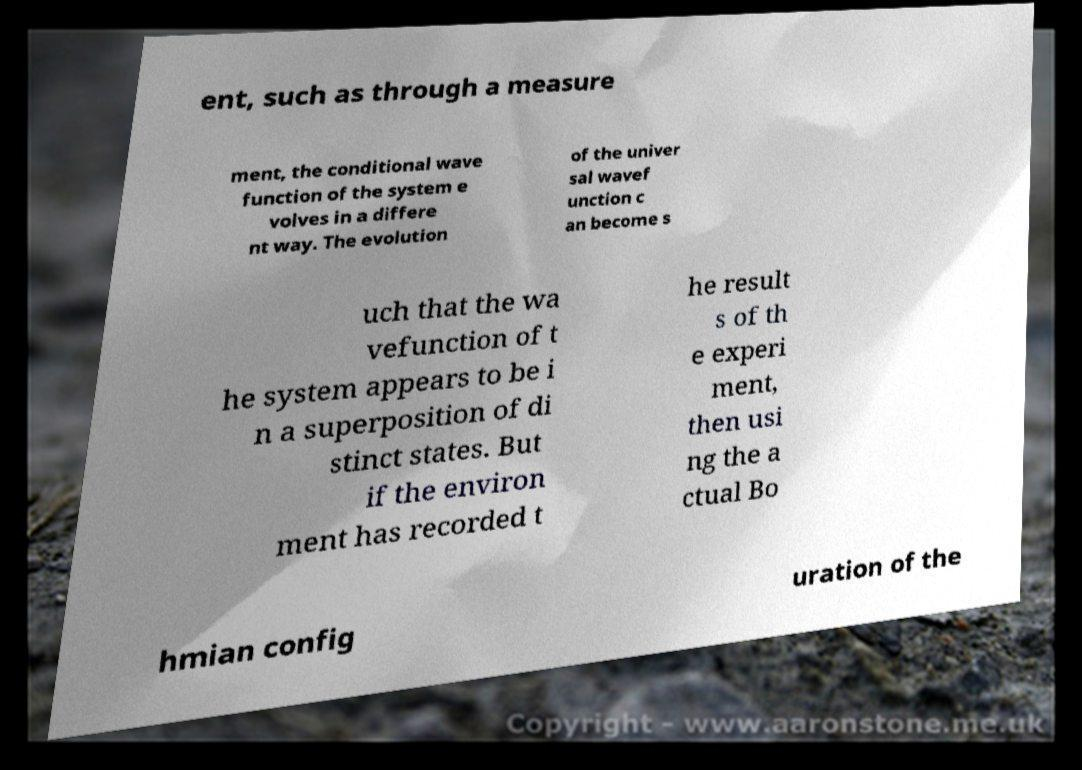Could you assist in decoding the text presented in this image and type it out clearly? ent, such as through a measure ment, the conditional wave function of the system e volves in a differe nt way. The evolution of the univer sal wavef unction c an become s uch that the wa vefunction of t he system appears to be i n a superposition of di stinct states. But if the environ ment has recorded t he result s of th e experi ment, then usi ng the a ctual Bo hmian config uration of the 